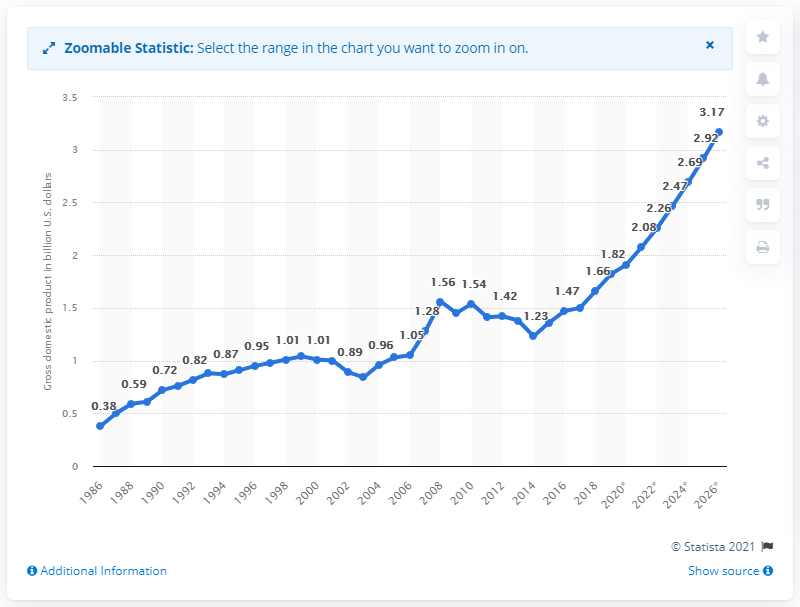Mention a couple of crucial points in this snapshot. The Gross Domestic Product (GDP) of the Gambia in 2018 was 1.66. 